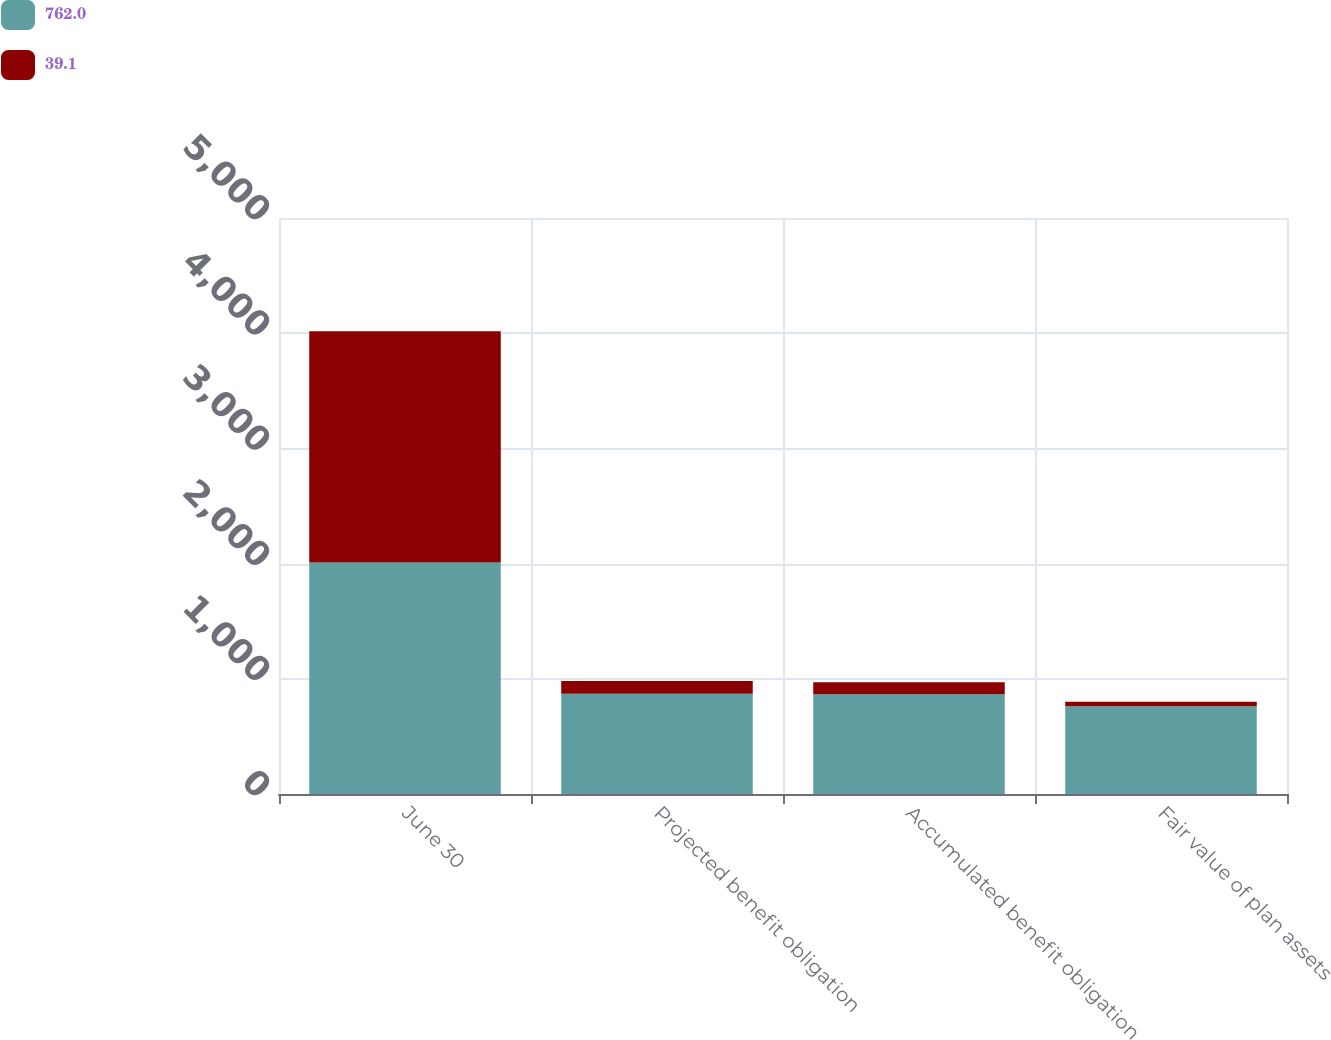<chart> <loc_0><loc_0><loc_500><loc_500><stacked_bar_chart><ecel><fcel>June 30<fcel>Projected benefit obligation<fcel>Accumulated benefit obligation<fcel>Fair value of plan assets<nl><fcel>762<fcel>2009<fcel>870.8<fcel>865.7<fcel>762<nl><fcel>39.1<fcel>2008<fcel>110.3<fcel>103.4<fcel>39.1<nl></chart> 